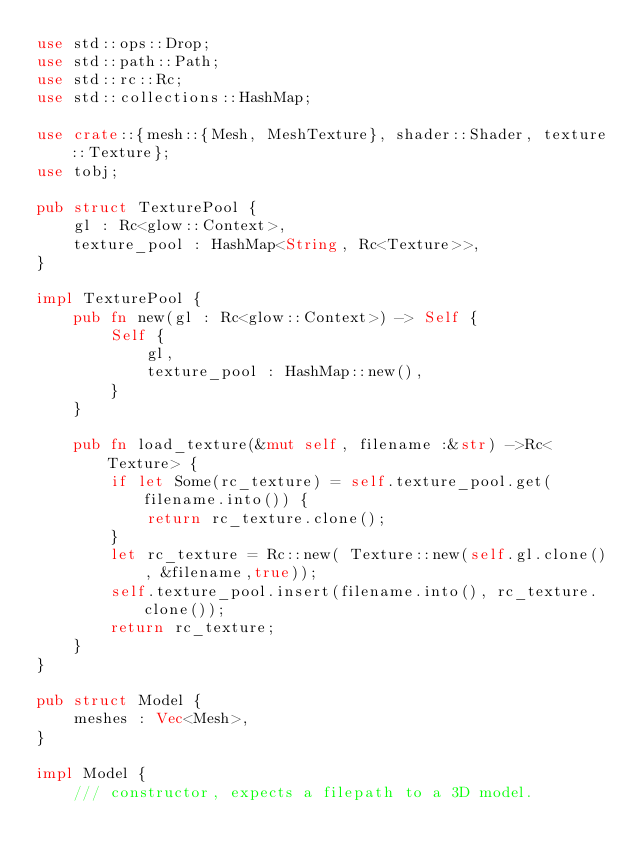Convert code to text. <code><loc_0><loc_0><loc_500><loc_500><_Rust_>use std::ops::Drop;
use std::path::Path;
use std::rc::Rc;
use std::collections::HashMap;

use crate::{mesh::{Mesh, MeshTexture}, shader::Shader, texture::Texture};
use tobj;

pub struct TexturePool {
    gl : Rc<glow::Context>,    
    texture_pool : HashMap<String, Rc<Texture>>,
}

impl TexturePool {
    pub fn new(gl : Rc<glow::Context>) -> Self {
        Self {
            gl,
            texture_pool : HashMap::new(),
        }
    }

    pub fn load_texture(&mut self, filename :&str) ->Rc<Texture> {
        if let Some(rc_texture) = self.texture_pool.get(filename.into()) {
            return rc_texture.clone();
        }
        let rc_texture = Rc::new( Texture::new(self.gl.clone(), &filename,true));
        self.texture_pool.insert(filename.into(), rc_texture.clone());
        return rc_texture;
    }
}

pub struct Model {
    meshes : Vec<Mesh>,
}

impl Model {
    /// constructor, expects a filepath to a 3D model.</code> 